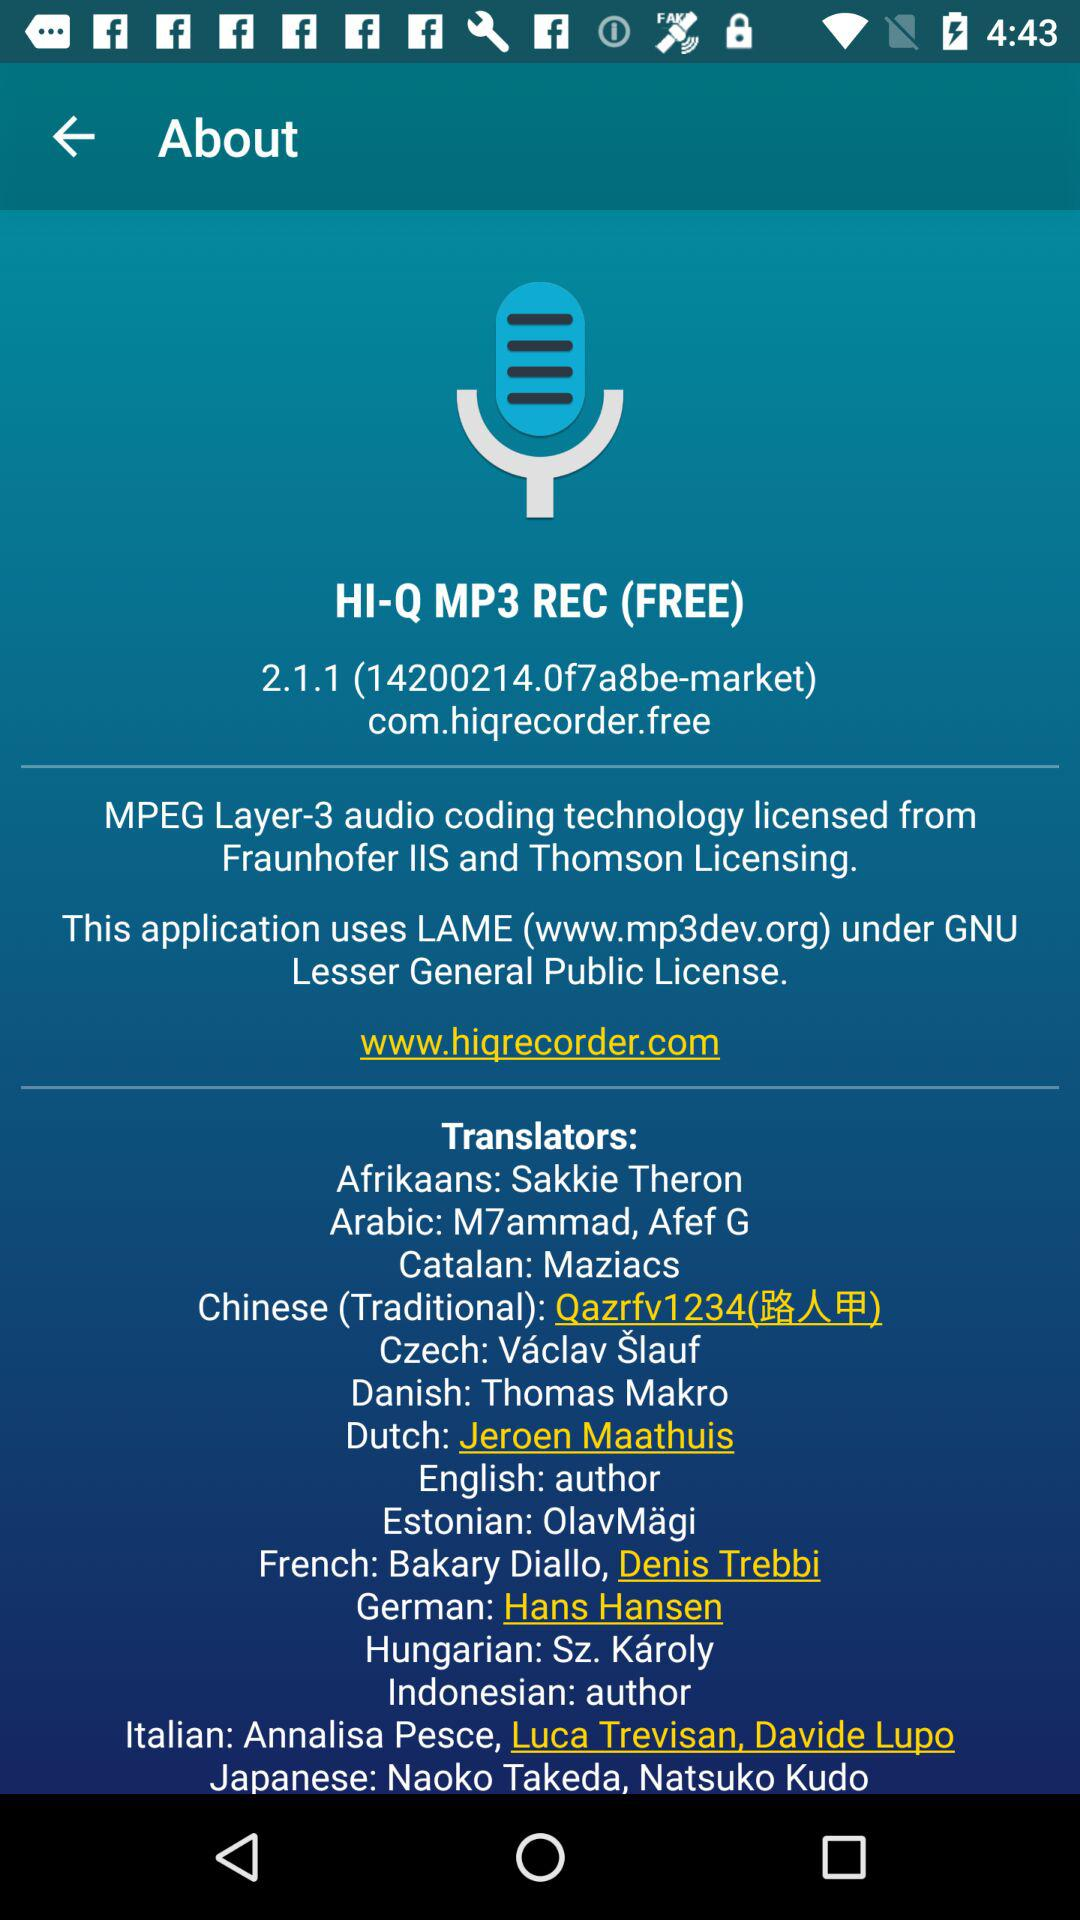What is the name of the application? The name of the application is "HI-Q MP3 REC (FREE)". 